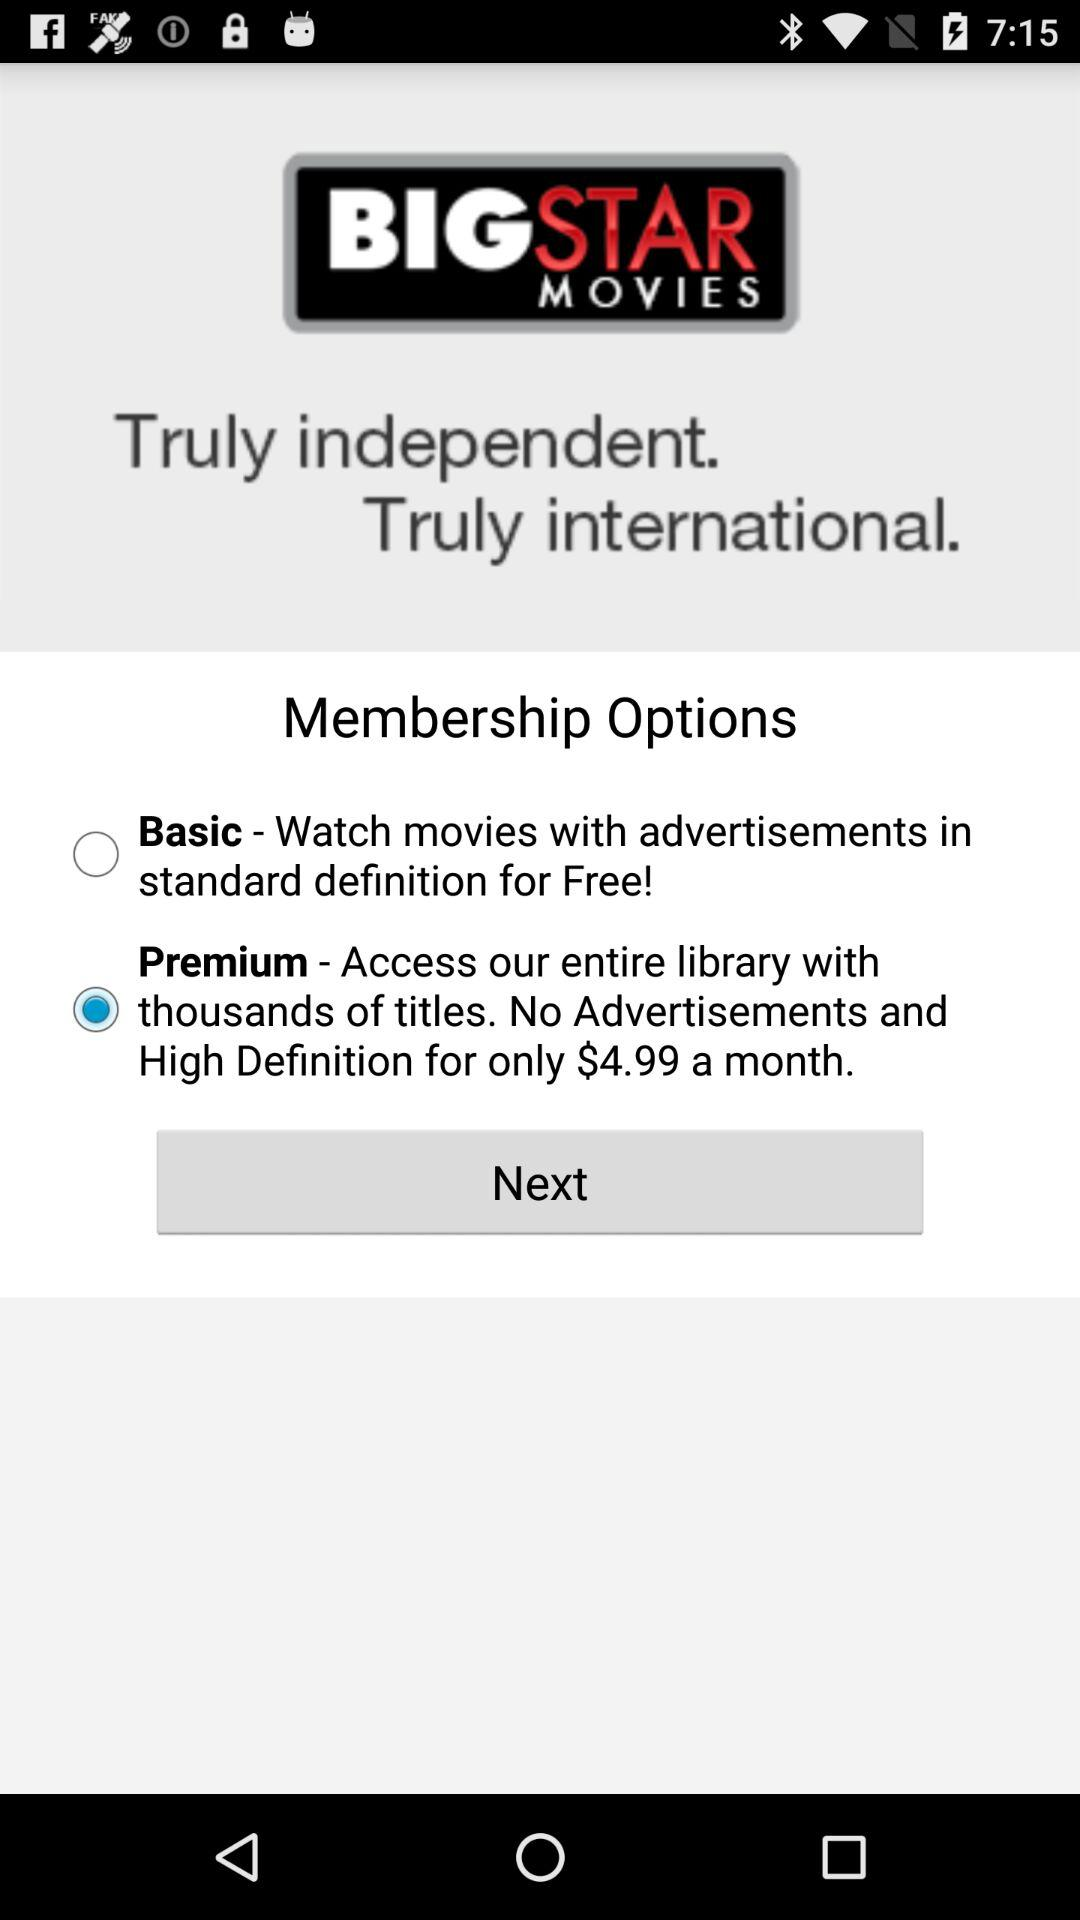How much more does the premium membership cost than the basic membership?
Answer the question using a single word or phrase. $4.99 